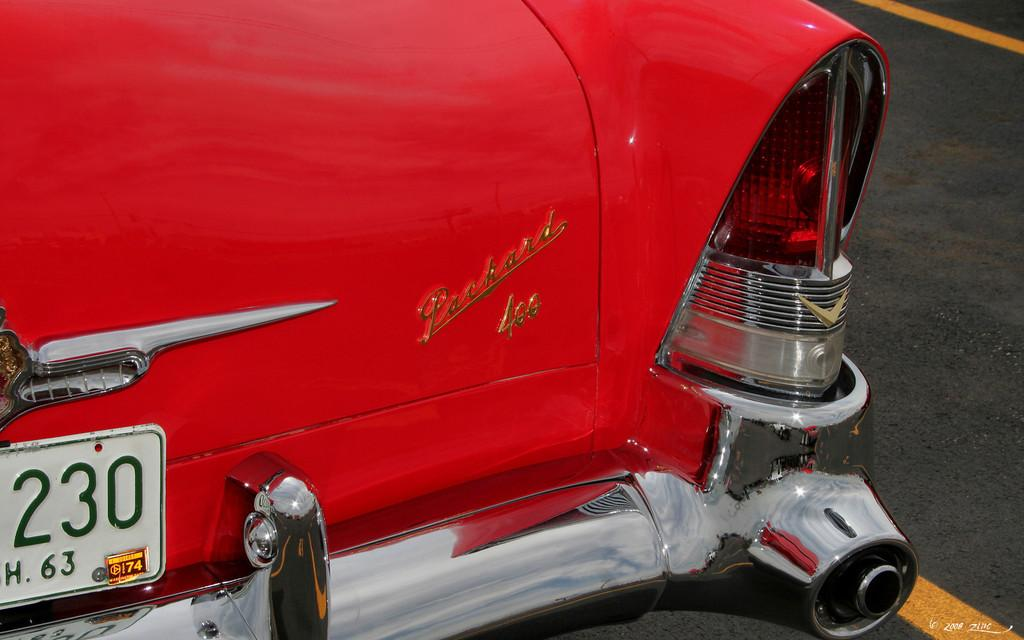What is the color of the vehicle in the image? The vehicle in the image is red. Where is the vehicle located? The vehicle is on the road. What can be seen on the road besides the vehicle? There are yellow color marks on the road. What is the color of the background in the image? The background of the image is black. Can you see the arm of the driver in the image? There is no driver or arm visible in the image; it only shows a red vehicle on the road with yellow marks. 